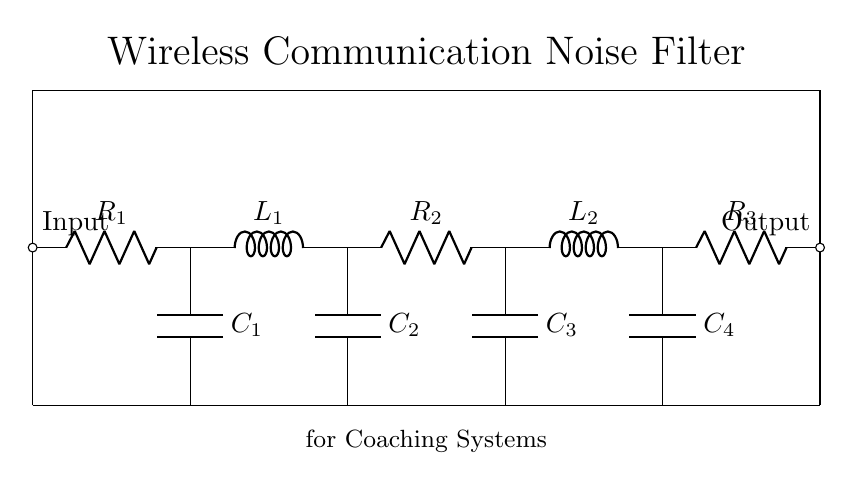what is the primary function of this circuit? The circuit is designed to filter out noise in wireless communication systems, helping to ensure clear signals for coaches.
Answer: noise filtering how many resistors are present in the circuit? There are three resistors labeled R1, R2, and R3 in the circuit, used in combination with capacitors and inductors to reduce noise.
Answer: three which component type appears most frequently in this circuit? The circuit includes four capacitors labeled C1, C2, C3, and C4, which are used to store and release energy to filter out noise.
Answer: capacitors what type of circuit is this? This circuit is an analog filter circuit since it utilizes passive components to process signals.
Answer: analog filter what is the role of L1 and L2 in this circuit? L1 and L2 are inductors that store energy in a magnetic field, contributing to the circuit's filtering capabilities by opposing changes in current.
Answer: energy storage which component is located at the output of the circuit? The last component at the output of the circuit is R3, which acts as a load resistor and is crucial for connecting the output to the next stage of the system.
Answer: R3 what does C4 do in this circuit? C4 is a capacitor that helps in filtering noise by allowing AC signals to pass while blocking DC signals, thus improving the quality of the output signal.
Answer: filtering noise 